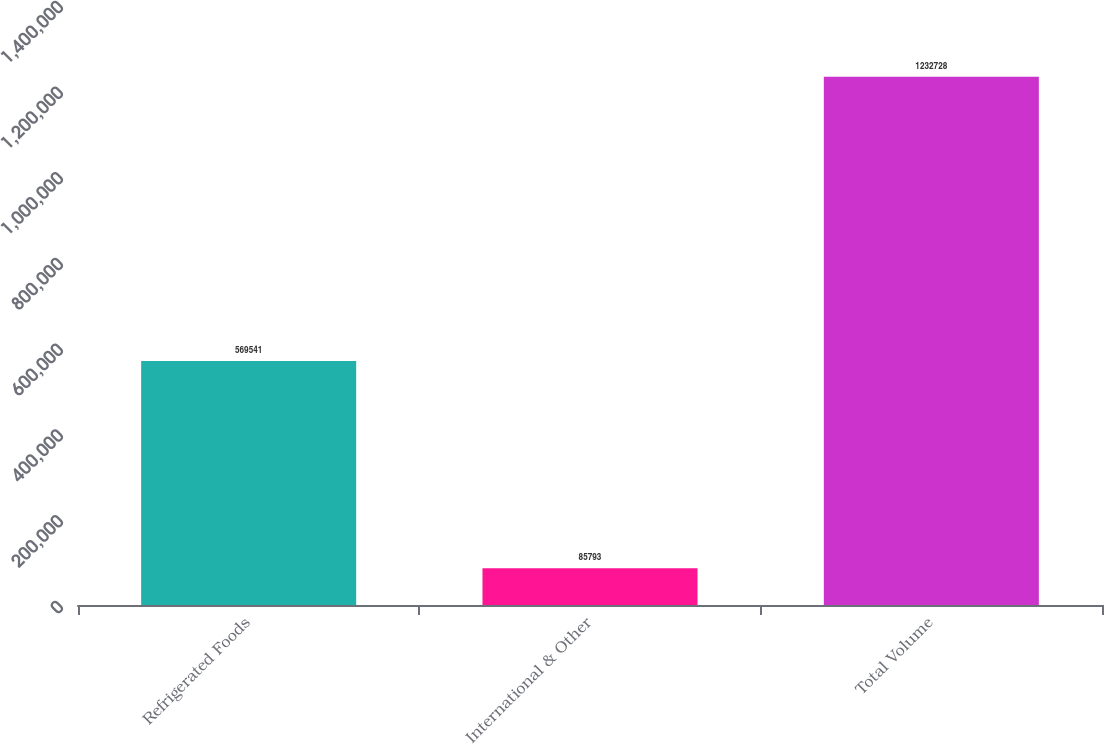<chart> <loc_0><loc_0><loc_500><loc_500><bar_chart><fcel>Refrigerated Foods<fcel>International & Other<fcel>Total Volume<nl><fcel>569541<fcel>85793<fcel>1.23273e+06<nl></chart> 